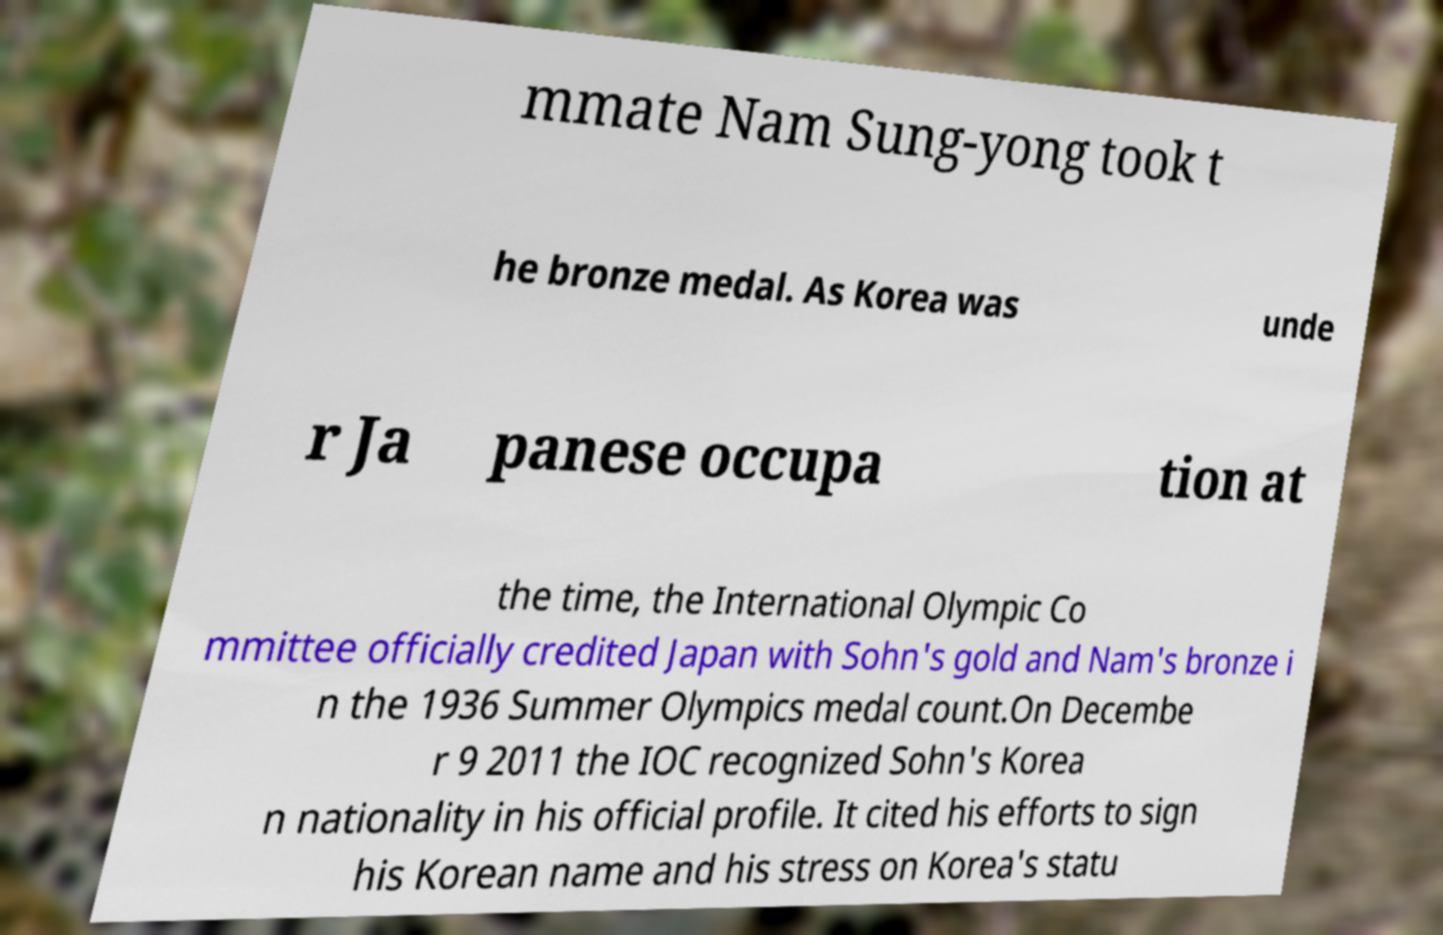Please read and relay the text visible in this image. What does it say? mmate Nam Sung-yong took t he bronze medal. As Korea was unde r Ja panese occupa tion at the time, the International Olympic Co mmittee officially credited Japan with Sohn's gold and Nam's bronze i n the 1936 Summer Olympics medal count.On Decembe r 9 2011 the IOC recognized Sohn's Korea n nationality in his official profile. It cited his efforts to sign his Korean name and his stress on Korea's statu 